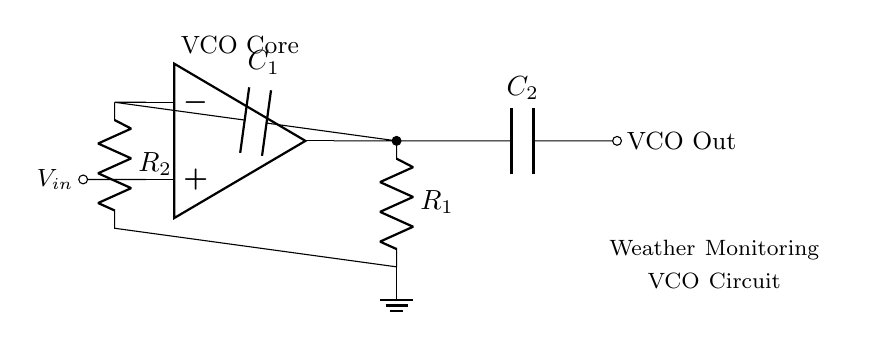What is the primary function of this circuit? The circuit's primary function is to generate a voltage-controlled oscillation, which is typically used for frequency modulation or signal generation, particularly in weather monitoring applications.
Answer: Voltage-controlled oscillator What type of amplifying component is used in this circuit? The circuit uses an operational amplifier (op amp) as its main amplifying component, which is essential for the voltage amplification and oscillation generation in this configuration.
Answer: Operational amplifier How many capacitors are present in the circuit diagram? There are two capacitors indicated in the circuit diagram, labeled C1 and C2, which play a vital role in determining the oscillation frequency and stability of the output signal.
Answer: Two What would be the effect of increasing R2? Increasing R2 would generally lead to a decrease in the feedback gain of the circuit, which could result in a lower amplitude of oscillation or affect the frequency stability, depending on the overall circuit design and parameters.
Answer: Decrease amplitude What is the purpose of C1 in the circuit? Capacitor C1 is connected in feedback and serves to couple the output signal back to the inverting input of the operational amplifier, which is crucial for maintaining the oscillation condition and frequency stabilization in the circuit.
Answer: Feedback stabilization What happens if the input voltage (Vin) is increased? An increase in the input voltage (Vin) typically raises the output frequency of the VCO, as this configuration is designed to vary the oscillation frequency based on the input voltage level, which is key for its operation in weather monitoring.
Answer: Increases output frequency 